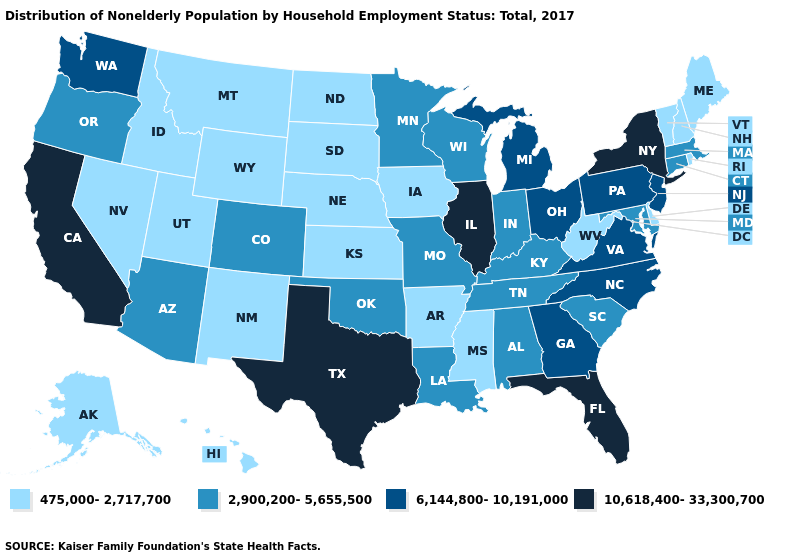Which states hav the highest value in the South?
Write a very short answer. Florida, Texas. Does Minnesota have the lowest value in the USA?
Short answer required. No. What is the highest value in the USA?
Give a very brief answer. 10,618,400-33,300,700. Does Maryland have the highest value in the USA?
Concise answer only. No. What is the value of Massachusetts?
Write a very short answer. 2,900,200-5,655,500. Does Iowa have the lowest value in the MidWest?
Concise answer only. Yes. Does the first symbol in the legend represent the smallest category?
Quick response, please. Yes. What is the value of Washington?
Short answer required. 6,144,800-10,191,000. Which states have the highest value in the USA?
Be succinct. California, Florida, Illinois, New York, Texas. Does Kansas have the lowest value in the USA?
Keep it brief. Yes. Name the states that have a value in the range 6,144,800-10,191,000?
Quick response, please. Georgia, Michigan, New Jersey, North Carolina, Ohio, Pennsylvania, Virginia, Washington. What is the highest value in the MidWest ?
Keep it brief. 10,618,400-33,300,700. Does the map have missing data?
Concise answer only. No. How many symbols are there in the legend?
Be succinct. 4. Name the states that have a value in the range 6,144,800-10,191,000?
Concise answer only. Georgia, Michigan, New Jersey, North Carolina, Ohio, Pennsylvania, Virginia, Washington. 